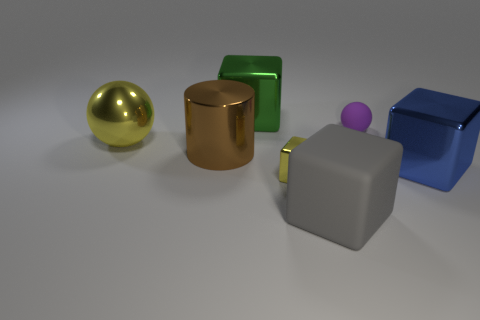Subtract all tiny blocks. How many blocks are left? 3 Subtract all cylinders. How many objects are left? 6 Add 3 blue cylinders. How many objects exist? 10 Subtract all green cubes. How many cubes are left? 3 Subtract all yellow metal balls. Subtract all large balls. How many objects are left? 5 Add 5 green things. How many green things are left? 6 Add 6 cubes. How many cubes exist? 10 Subtract 0 red cylinders. How many objects are left? 7 Subtract 2 spheres. How many spheres are left? 0 Subtract all blue cubes. Subtract all purple spheres. How many cubes are left? 3 